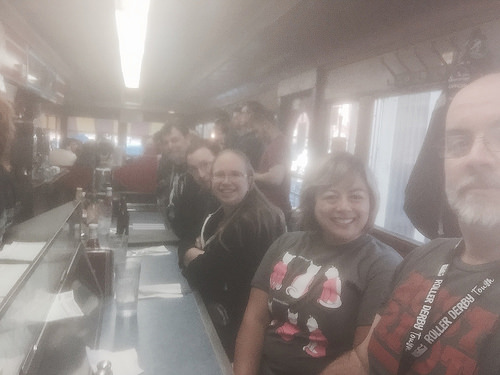<image>
Is there a light above the man? Yes. The light is positioned above the man in the vertical space, higher up in the scene. Is the woman to the left of the woman? Yes. From this viewpoint, the woman is positioned to the left side relative to the woman. 